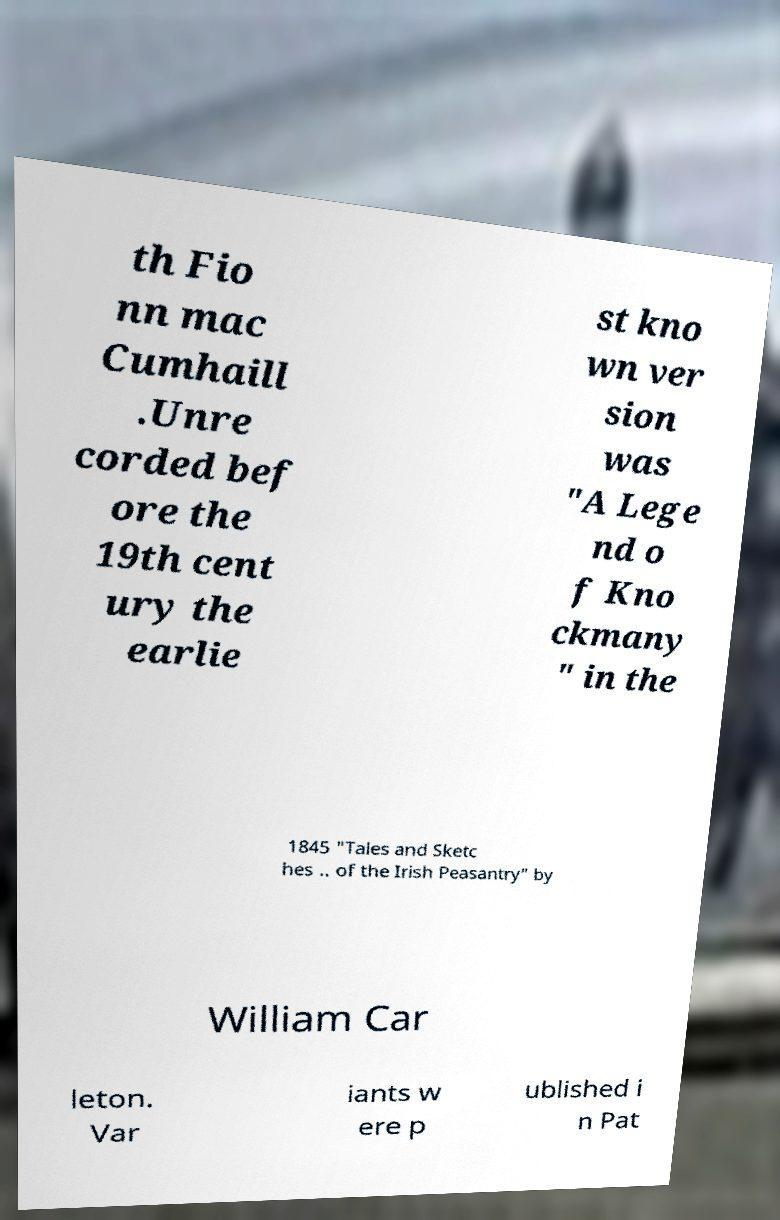I need the written content from this picture converted into text. Can you do that? th Fio nn mac Cumhaill .Unre corded bef ore the 19th cent ury the earlie st kno wn ver sion was "A Lege nd o f Kno ckmany " in the 1845 "Tales and Sketc hes .. of the Irish Peasantry" by William Car leton. Var iants w ere p ublished i n Pat 